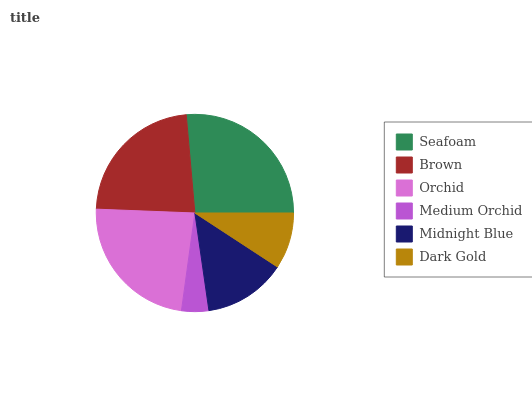Is Medium Orchid the minimum?
Answer yes or no. Yes. Is Seafoam the maximum?
Answer yes or no. Yes. Is Brown the minimum?
Answer yes or no. No. Is Brown the maximum?
Answer yes or no. No. Is Seafoam greater than Brown?
Answer yes or no. Yes. Is Brown less than Seafoam?
Answer yes or no. Yes. Is Brown greater than Seafoam?
Answer yes or no. No. Is Seafoam less than Brown?
Answer yes or no. No. Is Brown the high median?
Answer yes or no. Yes. Is Midnight Blue the low median?
Answer yes or no. Yes. Is Seafoam the high median?
Answer yes or no. No. Is Medium Orchid the low median?
Answer yes or no. No. 